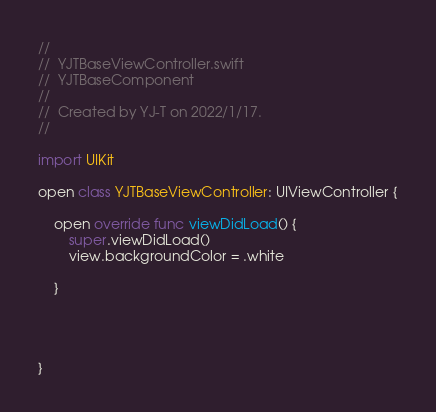<code> <loc_0><loc_0><loc_500><loc_500><_Swift_>//
//  YJTBaseViewController.swift
//  YJTBaseComponent
//
//  Created by YJ-T on 2022/1/17.
//

import UIKit

open class YJTBaseViewController: UIViewController {

    open override func viewDidLoad() {
        super.viewDidLoad()
        view.backgroundColor = .white
        
    }
    

    

}
</code> 